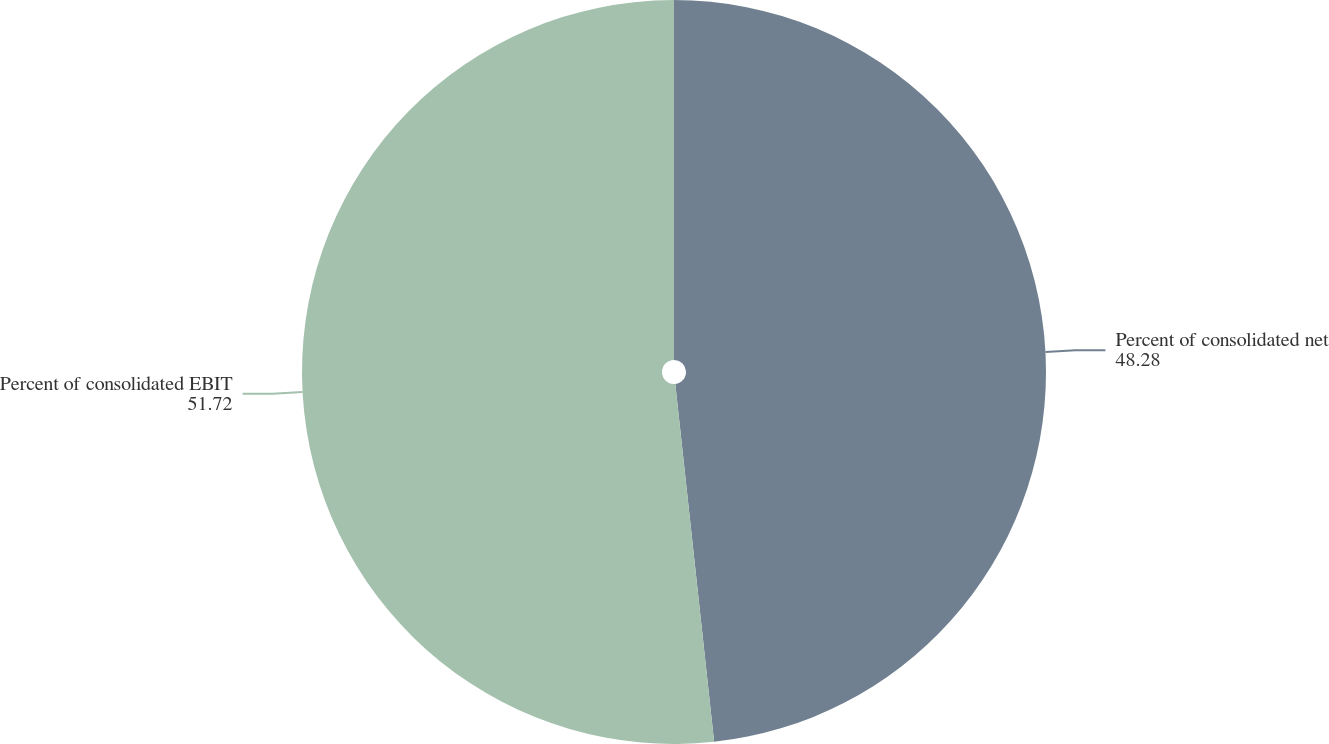Convert chart. <chart><loc_0><loc_0><loc_500><loc_500><pie_chart><fcel>Percent of consolidated net<fcel>Percent of consolidated EBIT<nl><fcel>48.28%<fcel>51.72%<nl></chart> 